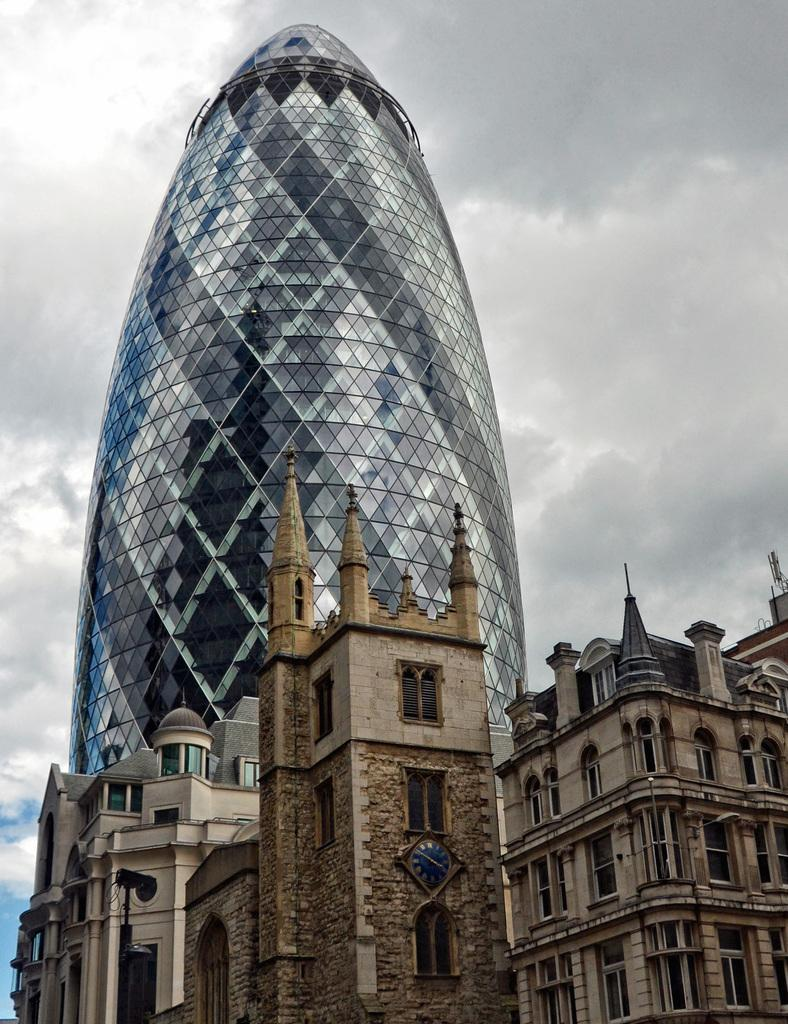What type of structure is present in the image? There is a building in the image. What feature can be seen on the building? There are windows in the building. What object is located in front of the building? There is a clock in front of the building. How would you describe the sky in the image? The sky is cloudy in the image. What color is the pole visible in the image? There is a black color pole in the image. What type of pot is being used to teach history in the image? There is no pot or history lesson present in the image. What type of hydrant can be seen near the pole in the image? There is no hydrant visible in the image; only a black color pole is present. 